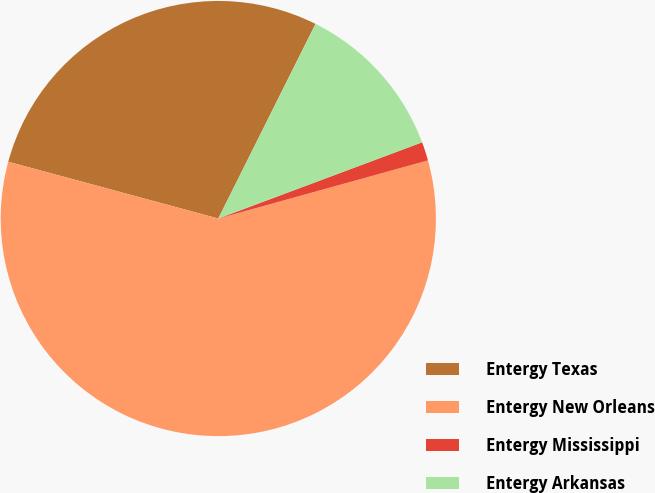Convert chart to OTSL. <chart><loc_0><loc_0><loc_500><loc_500><pie_chart><fcel>Entergy Texas<fcel>Entergy New Orleans<fcel>Entergy Mississippi<fcel>Entergy Arkansas<nl><fcel>28.17%<fcel>58.51%<fcel>1.39%<fcel>11.93%<nl></chart> 